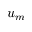Convert formula to latex. <formula><loc_0><loc_0><loc_500><loc_500>u _ { m }</formula> 